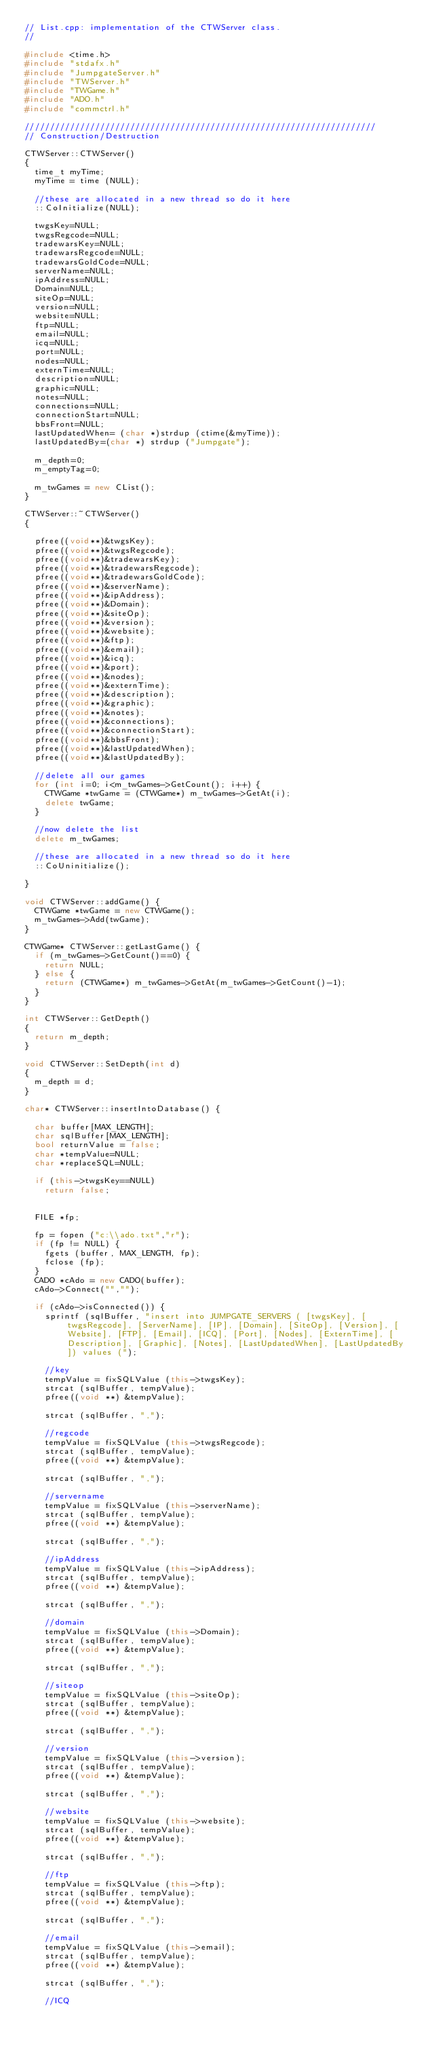Convert code to text. <code><loc_0><loc_0><loc_500><loc_500><_C++_>// List.cpp: implementation of the CTWServer class.
//

#include <time.h>
#include "stdafx.h"
#include "JumpgateServer.h"
#include "TWServer.h"
#include "TWGame.h"
#include "ADO.h"
#include "commctrl.h"

//////////////////////////////////////////////////////////////////////
// Construction/Destruction

CTWServer::CTWServer()
{
	time_t myTime;
	myTime = time (NULL);

	//these are allocated in a new thread so do it here
	::CoInitialize(NULL);

	twgsKey=NULL;
	twgsRegcode=NULL;
	tradewarsKey=NULL;
	tradewarsRegcode=NULL;
	tradewarsGoldCode=NULL;
	serverName=NULL;
	ipAddress=NULL;
	Domain=NULL;
	siteOp=NULL;
	version=NULL;
	website=NULL;
	ftp=NULL;
	email=NULL;
	icq=NULL;
	port=NULL;
	nodes=NULL;
	externTime=NULL;
	description=NULL;
	graphic=NULL;
	notes=NULL;
	connections=NULL;
	connectionStart=NULL;
	bbsFront=NULL;
	lastUpdatedWhen= (char *)strdup (ctime(&myTime));
	lastUpdatedBy=(char *) strdup ("Jumpgate");

	m_depth=0;
	m_emptyTag=0;

	m_twGames = new CList();
}

CTWServer::~CTWServer()
{

	pfree((void**)&twgsKey);
	pfree((void**)&twgsRegcode);
	pfree((void**)&tradewarsKey);
	pfree((void**)&tradewarsRegcode);
	pfree((void**)&tradewarsGoldCode);
	pfree((void**)&serverName);
	pfree((void**)&ipAddress);
	pfree((void**)&Domain);
	pfree((void**)&siteOp);
	pfree((void**)&version);
	pfree((void**)&website);
	pfree((void**)&ftp);
	pfree((void**)&email);
	pfree((void**)&icq);
	pfree((void**)&port);
	pfree((void**)&nodes);
	pfree((void**)&externTime);
	pfree((void**)&description);
	pfree((void**)&graphic);
	pfree((void**)&notes);
	pfree((void**)&connections);
	pfree((void**)&connectionStart);
	pfree((void**)&bbsFront);
	pfree((void**)&lastUpdatedWhen);
	pfree((void**)&lastUpdatedBy);

	//delete all our games
	for (int i=0; i<m_twGames->GetCount(); i++) {
		CTWGame *twGame = (CTWGame*) m_twGames->GetAt(i);
		delete twGame;
	}

	//now delete the list
	delete m_twGames;

	//these are allocated in a new thread so do it here
	::CoUninitialize();

}

void CTWServer::addGame() {
	CTWGame *twGame = new CTWGame();
	m_twGames->Add(twGame);
}

CTWGame* CTWServer::getLastGame() {
	if (m_twGames->GetCount()==0) {
		return NULL;
	} else {
		return (CTWGame*) m_twGames->GetAt(m_twGames->GetCount()-1);
	}
}

int CTWServer::GetDepth()
{
	return m_depth;
}

void CTWServer::SetDepth(int d)
{
	m_depth = d;
}

char* CTWServer::insertIntoDatabase() {

	char buffer[MAX_LENGTH];
	char sqlBuffer[MAX_LENGTH];
	bool returnValue = false;
	char *tempValue=NULL;
	char *replaceSQL=NULL;

	if (this->twgsKey==NULL)
		return false;


	FILE *fp;

	fp = fopen ("c:\\ado.txt","r");
	if (fp != NULL) {
		fgets (buffer, MAX_LENGTH, fp);
		fclose (fp);
	}
	CADO *cAdo = new CADO(buffer);
	cAdo->Connect("","");

	if (cAdo->isConnected()) {
		sprintf (sqlBuffer, "insert into JUMPGATE_SERVERS ( [twgsKey], [twgsRegcode], [ServerName], [IP], [Domain], [SiteOp], [Version], [Website], [FTP], [Email], [ICQ], [Port], [Nodes], [ExternTime], [Description], [Graphic], [Notes], [LastUpdatedWhen], [LastUpdatedBy]) values (");

		//key
		tempValue = fixSQLValue (this->twgsKey);
		strcat (sqlBuffer, tempValue);
		pfree((void **) &tempValue);

		strcat (sqlBuffer, ",");

		//regcode
		tempValue = fixSQLValue (this->twgsRegcode);
		strcat (sqlBuffer, tempValue);
		pfree((void **) &tempValue);

		strcat (sqlBuffer, ",");

		//servername
		tempValue = fixSQLValue (this->serverName);
		strcat (sqlBuffer, tempValue);
		pfree((void **) &tempValue);

		strcat (sqlBuffer, ",");

		//ipAddress
		tempValue = fixSQLValue (this->ipAddress);
		strcat (sqlBuffer, tempValue);
		pfree((void **) &tempValue);

		strcat (sqlBuffer, ",");

		//domain
		tempValue = fixSQLValue (this->Domain);
		strcat (sqlBuffer, tempValue);
		pfree((void **) &tempValue);

		strcat (sqlBuffer, ",");

		//siteop
		tempValue = fixSQLValue (this->siteOp);
		strcat (sqlBuffer, tempValue);
		pfree((void **) &tempValue);

		strcat (sqlBuffer, ",");

		//version
		tempValue = fixSQLValue (this->version);
		strcat (sqlBuffer, tempValue);
		pfree((void **) &tempValue);

		strcat (sqlBuffer, ",");

		//website
		tempValue = fixSQLValue (this->website);
		strcat (sqlBuffer, tempValue);
		pfree((void **) &tempValue);

		strcat (sqlBuffer, ",");

		//ftp
		tempValue = fixSQLValue (this->ftp);
		strcat (sqlBuffer, tempValue);
		pfree((void **) &tempValue);

		strcat (sqlBuffer, ",");

		//email
		tempValue = fixSQLValue (this->email);
		strcat (sqlBuffer, tempValue);
		pfree((void **) &tempValue);

		strcat (sqlBuffer, ",");

		//ICQ</code> 